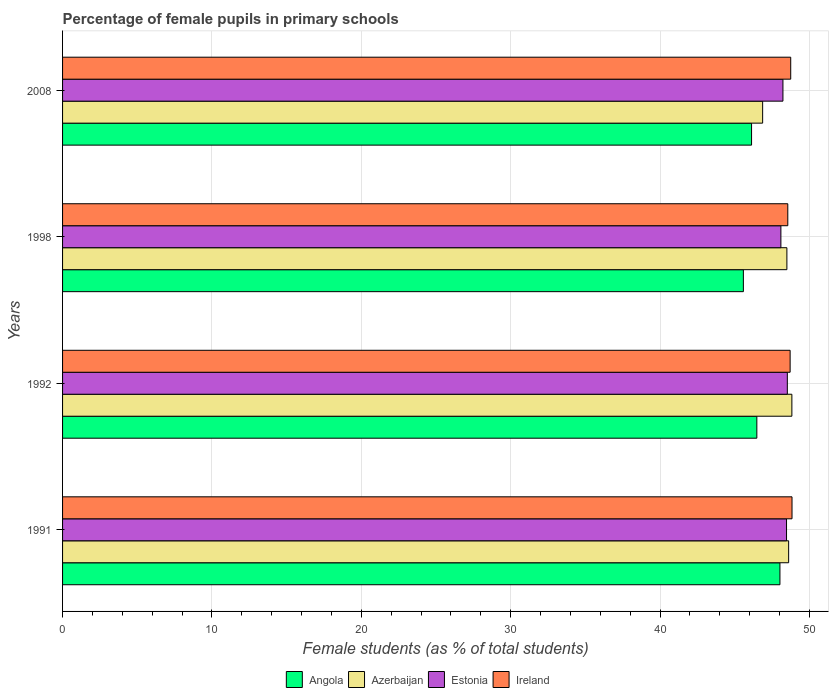Are the number of bars per tick equal to the number of legend labels?
Offer a very short reply. Yes. What is the label of the 3rd group of bars from the top?
Offer a very short reply. 1992. In how many cases, is the number of bars for a given year not equal to the number of legend labels?
Your answer should be very brief. 0. What is the percentage of female pupils in primary schools in Ireland in 2008?
Make the answer very short. 48.74. Across all years, what is the maximum percentage of female pupils in primary schools in Ireland?
Offer a terse response. 48.83. Across all years, what is the minimum percentage of female pupils in primary schools in Azerbaijan?
Ensure brevity in your answer.  46.87. What is the total percentage of female pupils in primary schools in Azerbaijan in the graph?
Make the answer very short. 192.78. What is the difference between the percentage of female pupils in primary schools in Angola in 1992 and that in 2008?
Provide a short and direct response. 0.35. What is the difference between the percentage of female pupils in primary schools in Estonia in 1992 and the percentage of female pupils in primary schools in Azerbaijan in 1998?
Offer a very short reply. 0.03. What is the average percentage of female pupils in primary schools in Azerbaijan per year?
Provide a succinct answer. 48.2. In the year 1998, what is the difference between the percentage of female pupils in primary schools in Estonia and percentage of female pupils in primary schools in Angola?
Your answer should be very brief. 2.51. What is the ratio of the percentage of female pupils in primary schools in Estonia in 1991 to that in 2008?
Make the answer very short. 1. What is the difference between the highest and the second highest percentage of female pupils in primary schools in Estonia?
Offer a terse response. 0.05. What is the difference between the highest and the lowest percentage of female pupils in primary schools in Estonia?
Keep it short and to the point. 0.43. In how many years, is the percentage of female pupils in primary schools in Angola greater than the average percentage of female pupils in primary schools in Angola taken over all years?
Make the answer very short. 1. What does the 4th bar from the top in 1998 represents?
Keep it short and to the point. Angola. What does the 2nd bar from the bottom in 2008 represents?
Offer a terse response. Azerbaijan. How many bars are there?
Make the answer very short. 16. Are all the bars in the graph horizontal?
Offer a terse response. Yes. What is the difference between two consecutive major ticks on the X-axis?
Provide a succinct answer. 10. Does the graph contain any zero values?
Offer a terse response. No. How are the legend labels stacked?
Provide a short and direct response. Horizontal. What is the title of the graph?
Provide a succinct answer. Percentage of female pupils in primary schools. Does "Brunei Darussalam" appear as one of the legend labels in the graph?
Make the answer very short. No. What is the label or title of the X-axis?
Offer a very short reply. Female students (as % of total students). What is the label or title of the Y-axis?
Provide a succinct answer. Years. What is the Female students (as % of total students) in Angola in 1991?
Your answer should be very brief. 48.02. What is the Female students (as % of total students) in Azerbaijan in 1991?
Your answer should be compact. 48.61. What is the Female students (as % of total students) of Estonia in 1991?
Your response must be concise. 48.46. What is the Female students (as % of total students) of Ireland in 1991?
Your answer should be compact. 48.83. What is the Female students (as % of total students) of Angola in 1992?
Your answer should be very brief. 46.48. What is the Female students (as % of total students) of Azerbaijan in 1992?
Ensure brevity in your answer.  48.82. What is the Female students (as % of total students) of Estonia in 1992?
Ensure brevity in your answer.  48.52. What is the Female students (as % of total students) in Ireland in 1992?
Make the answer very short. 48.71. What is the Female students (as % of total students) of Angola in 1998?
Keep it short and to the point. 45.58. What is the Female students (as % of total students) of Azerbaijan in 1998?
Make the answer very short. 48.49. What is the Female students (as % of total students) of Estonia in 1998?
Provide a short and direct response. 48.09. What is the Female students (as % of total students) of Ireland in 1998?
Give a very brief answer. 48.55. What is the Female students (as % of total students) in Angola in 2008?
Offer a very short reply. 46.12. What is the Female students (as % of total students) in Azerbaijan in 2008?
Make the answer very short. 46.87. What is the Female students (as % of total students) of Estonia in 2008?
Provide a succinct answer. 48.22. What is the Female students (as % of total students) of Ireland in 2008?
Your response must be concise. 48.74. Across all years, what is the maximum Female students (as % of total students) in Angola?
Keep it short and to the point. 48.02. Across all years, what is the maximum Female students (as % of total students) in Azerbaijan?
Your answer should be compact. 48.82. Across all years, what is the maximum Female students (as % of total students) of Estonia?
Your response must be concise. 48.52. Across all years, what is the maximum Female students (as % of total students) of Ireland?
Keep it short and to the point. 48.83. Across all years, what is the minimum Female students (as % of total students) of Angola?
Provide a short and direct response. 45.58. Across all years, what is the minimum Female students (as % of total students) of Azerbaijan?
Your answer should be very brief. 46.87. Across all years, what is the minimum Female students (as % of total students) of Estonia?
Give a very brief answer. 48.09. Across all years, what is the minimum Female students (as % of total students) in Ireland?
Keep it short and to the point. 48.55. What is the total Female students (as % of total students) in Angola in the graph?
Give a very brief answer. 186.2. What is the total Female students (as % of total students) in Azerbaijan in the graph?
Provide a short and direct response. 192.78. What is the total Female students (as % of total students) in Estonia in the graph?
Your answer should be compact. 193.29. What is the total Female students (as % of total students) of Ireland in the graph?
Your answer should be very brief. 194.83. What is the difference between the Female students (as % of total students) of Angola in 1991 and that in 1992?
Your answer should be very brief. 1.55. What is the difference between the Female students (as % of total students) of Azerbaijan in 1991 and that in 1992?
Your answer should be very brief. -0.22. What is the difference between the Female students (as % of total students) in Estonia in 1991 and that in 1992?
Give a very brief answer. -0.05. What is the difference between the Female students (as % of total students) of Ireland in 1991 and that in 1992?
Your response must be concise. 0.13. What is the difference between the Female students (as % of total students) in Angola in 1991 and that in 1998?
Make the answer very short. 2.45. What is the difference between the Female students (as % of total students) in Azerbaijan in 1991 and that in 1998?
Keep it short and to the point. 0.12. What is the difference between the Female students (as % of total students) of Estonia in 1991 and that in 1998?
Keep it short and to the point. 0.38. What is the difference between the Female students (as % of total students) in Ireland in 1991 and that in 1998?
Your response must be concise. 0.28. What is the difference between the Female students (as % of total students) of Angola in 1991 and that in 2008?
Provide a succinct answer. 1.9. What is the difference between the Female students (as % of total students) in Azerbaijan in 1991 and that in 2008?
Make the answer very short. 1.74. What is the difference between the Female students (as % of total students) of Estonia in 1991 and that in 2008?
Ensure brevity in your answer.  0.24. What is the difference between the Female students (as % of total students) of Ireland in 1991 and that in 2008?
Keep it short and to the point. 0.09. What is the difference between the Female students (as % of total students) in Angola in 1992 and that in 1998?
Make the answer very short. 0.9. What is the difference between the Female students (as % of total students) in Azerbaijan in 1992 and that in 1998?
Ensure brevity in your answer.  0.33. What is the difference between the Female students (as % of total students) in Estonia in 1992 and that in 1998?
Your answer should be compact. 0.43. What is the difference between the Female students (as % of total students) in Ireland in 1992 and that in 1998?
Provide a short and direct response. 0.16. What is the difference between the Female students (as % of total students) of Angola in 1992 and that in 2008?
Give a very brief answer. 0.35. What is the difference between the Female students (as % of total students) in Azerbaijan in 1992 and that in 2008?
Offer a terse response. 1.96. What is the difference between the Female students (as % of total students) in Estonia in 1992 and that in 2008?
Offer a very short reply. 0.29. What is the difference between the Female students (as % of total students) of Ireland in 1992 and that in 2008?
Ensure brevity in your answer.  -0.04. What is the difference between the Female students (as % of total students) in Angola in 1998 and that in 2008?
Your answer should be compact. -0.55. What is the difference between the Female students (as % of total students) of Azerbaijan in 1998 and that in 2008?
Offer a terse response. 1.62. What is the difference between the Female students (as % of total students) in Estonia in 1998 and that in 2008?
Keep it short and to the point. -0.14. What is the difference between the Female students (as % of total students) in Ireland in 1998 and that in 2008?
Ensure brevity in your answer.  -0.2. What is the difference between the Female students (as % of total students) of Angola in 1991 and the Female students (as % of total students) of Azerbaijan in 1992?
Offer a terse response. -0.8. What is the difference between the Female students (as % of total students) in Angola in 1991 and the Female students (as % of total students) in Estonia in 1992?
Provide a short and direct response. -0.5. What is the difference between the Female students (as % of total students) of Angola in 1991 and the Female students (as % of total students) of Ireland in 1992?
Your answer should be very brief. -0.68. What is the difference between the Female students (as % of total students) in Azerbaijan in 1991 and the Female students (as % of total students) in Estonia in 1992?
Your answer should be very brief. 0.09. What is the difference between the Female students (as % of total students) of Azerbaijan in 1991 and the Female students (as % of total students) of Ireland in 1992?
Give a very brief answer. -0.1. What is the difference between the Female students (as % of total students) of Estonia in 1991 and the Female students (as % of total students) of Ireland in 1992?
Your answer should be very brief. -0.24. What is the difference between the Female students (as % of total students) of Angola in 1991 and the Female students (as % of total students) of Azerbaijan in 1998?
Your answer should be very brief. -0.47. What is the difference between the Female students (as % of total students) in Angola in 1991 and the Female students (as % of total students) in Estonia in 1998?
Your answer should be very brief. -0.06. What is the difference between the Female students (as % of total students) of Angola in 1991 and the Female students (as % of total students) of Ireland in 1998?
Your answer should be compact. -0.53. What is the difference between the Female students (as % of total students) of Azerbaijan in 1991 and the Female students (as % of total students) of Estonia in 1998?
Make the answer very short. 0.52. What is the difference between the Female students (as % of total students) of Azerbaijan in 1991 and the Female students (as % of total students) of Ireland in 1998?
Keep it short and to the point. 0.06. What is the difference between the Female students (as % of total students) of Estonia in 1991 and the Female students (as % of total students) of Ireland in 1998?
Your answer should be very brief. -0.08. What is the difference between the Female students (as % of total students) of Angola in 1991 and the Female students (as % of total students) of Azerbaijan in 2008?
Give a very brief answer. 1.16. What is the difference between the Female students (as % of total students) of Angola in 1991 and the Female students (as % of total students) of Estonia in 2008?
Give a very brief answer. -0.2. What is the difference between the Female students (as % of total students) in Angola in 1991 and the Female students (as % of total students) in Ireland in 2008?
Your answer should be compact. -0.72. What is the difference between the Female students (as % of total students) in Azerbaijan in 1991 and the Female students (as % of total students) in Estonia in 2008?
Keep it short and to the point. 0.38. What is the difference between the Female students (as % of total students) in Azerbaijan in 1991 and the Female students (as % of total students) in Ireland in 2008?
Your answer should be very brief. -0.14. What is the difference between the Female students (as % of total students) of Estonia in 1991 and the Female students (as % of total students) of Ireland in 2008?
Your answer should be very brief. -0.28. What is the difference between the Female students (as % of total students) in Angola in 1992 and the Female students (as % of total students) in Azerbaijan in 1998?
Your answer should be compact. -2.01. What is the difference between the Female students (as % of total students) in Angola in 1992 and the Female students (as % of total students) in Estonia in 1998?
Ensure brevity in your answer.  -1.61. What is the difference between the Female students (as % of total students) of Angola in 1992 and the Female students (as % of total students) of Ireland in 1998?
Offer a terse response. -2.07. What is the difference between the Female students (as % of total students) of Azerbaijan in 1992 and the Female students (as % of total students) of Estonia in 1998?
Give a very brief answer. 0.74. What is the difference between the Female students (as % of total students) of Azerbaijan in 1992 and the Female students (as % of total students) of Ireland in 1998?
Give a very brief answer. 0.27. What is the difference between the Female students (as % of total students) in Estonia in 1992 and the Female students (as % of total students) in Ireland in 1998?
Give a very brief answer. -0.03. What is the difference between the Female students (as % of total students) of Angola in 1992 and the Female students (as % of total students) of Azerbaijan in 2008?
Provide a short and direct response. -0.39. What is the difference between the Female students (as % of total students) of Angola in 1992 and the Female students (as % of total students) of Estonia in 2008?
Make the answer very short. -1.75. What is the difference between the Female students (as % of total students) in Angola in 1992 and the Female students (as % of total students) in Ireland in 2008?
Provide a short and direct response. -2.27. What is the difference between the Female students (as % of total students) in Azerbaijan in 1992 and the Female students (as % of total students) in Estonia in 2008?
Ensure brevity in your answer.  0.6. What is the difference between the Female students (as % of total students) of Azerbaijan in 1992 and the Female students (as % of total students) of Ireland in 2008?
Your response must be concise. 0.08. What is the difference between the Female students (as % of total students) in Estonia in 1992 and the Female students (as % of total students) in Ireland in 2008?
Provide a succinct answer. -0.23. What is the difference between the Female students (as % of total students) of Angola in 1998 and the Female students (as % of total students) of Azerbaijan in 2008?
Offer a very short reply. -1.29. What is the difference between the Female students (as % of total students) of Angola in 1998 and the Female students (as % of total students) of Estonia in 2008?
Keep it short and to the point. -2.65. What is the difference between the Female students (as % of total students) of Angola in 1998 and the Female students (as % of total students) of Ireland in 2008?
Provide a short and direct response. -3.17. What is the difference between the Female students (as % of total students) of Azerbaijan in 1998 and the Female students (as % of total students) of Estonia in 2008?
Make the answer very short. 0.27. What is the difference between the Female students (as % of total students) of Azerbaijan in 1998 and the Female students (as % of total students) of Ireland in 2008?
Offer a very short reply. -0.26. What is the difference between the Female students (as % of total students) in Estonia in 1998 and the Female students (as % of total students) in Ireland in 2008?
Provide a succinct answer. -0.66. What is the average Female students (as % of total students) in Angola per year?
Your response must be concise. 46.55. What is the average Female students (as % of total students) of Azerbaijan per year?
Offer a very short reply. 48.2. What is the average Female students (as % of total students) in Estonia per year?
Give a very brief answer. 48.32. What is the average Female students (as % of total students) of Ireland per year?
Provide a succinct answer. 48.71. In the year 1991, what is the difference between the Female students (as % of total students) of Angola and Female students (as % of total students) of Azerbaijan?
Your answer should be very brief. -0.58. In the year 1991, what is the difference between the Female students (as % of total students) in Angola and Female students (as % of total students) in Estonia?
Offer a very short reply. -0.44. In the year 1991, what is the difference between the Female students (as % of total students) of Angola and Female students (as % of total students) of Ireland?
Provide a short and direct response. -0.81. In the year 1991, what is the difference between the Female students (as % of total students) in Azerbaijan and Female students (as % of total students) in Estonia?
Your answer should be very brief. 0.14. In the year 1991, what is the difference between the Female students (as % of total students) of Azerbaijan and Female students (as % of total students) of Ireland?
Ensure brevity in your answer.  -0.23. In the year 1991, what is the difference between the Female students (as % of total students) of Estonia and Female students (as % of total students) of Ireland?
Provide a short and direct response. -0.37. In the year 1992, what is the difference between the Female students (as % of total students) of Angola and Female students (as % of total students) of Azerbaijan?
Your response must be concise. -2.35. In the year 1992, what is the difference between the Female students (as % of total students) of Angola and Female students (as % of total students) of Estonia?
Your answer should be compact. -2.04. In the year 1992, what is the difference between the Female students (as % of total students) in Angola and Female students (as % of total students) in Ireland?
Give a very brief answer. -2.23. In the year 1992, what is the difference between the Female students (as % of total students) of Azerbaijan and Female students (as % of total students) of Estonia?
Ensure brevity in your answer.  0.3. In the year 1992, what is the difference between the Female students (as % of total students) of Azerbaijan and Female students (as % of total students) of Ireland?
Ensure brevity in your answer.  0.12. In the year 1992, what is the difference between the Female students (as % of total students) in Estonia and Female students (as % of total students) in Ireland?
Your answer should be very brief. -0.19. In the year 1998, what is the difference between the Female students (as % of total students) in Angola and Female students (as % of total students) in Azerbaijan?
Offer a very short reply. -2.91. In the year 1998, what is the difference between the Female students (as % of total students) in Angola and Female students (as % of total students) in Estonia?
Give a very brief answer. -2.51. In the year 1998, what is the difference between the Female students (as % of total students) of Angola and Female students (as % of total students) of Ireland?
Give a very brief answer. -2.97. In the year 1998, what is the difference between the Female students (as % of total students) in Azerbaijan and Female students (as % of total students) in Estonia?
Offer a terse response. 0.4. In the year 1998, what is the difference between the Female students (as % of total students) of Azerbaijan and Female students (as % of total students) of Ireland?
Keep it short and to the point. -0.06. In the year 1998, what is the difference between the Female students (as % of total students) in Estonia and Female students (as % of total students) in Ireland?
Ensure brevity in your answer.  -0.46. In the year 2008, what is the difference between the Female students (as % of total students) in Angola and Female students (as % of total students) in Azerbaijan?
Offer a terse response. -0.74. In the year 2008, what is the difference between the Female students (as % of total students) of Angola and Female students (as % of total students) of Estonia?
Offer a very short reply. -2.1. In the year 2008, what is the difference between the Female students (as % of total students) of Angola and Female students (as % of total students) of Ireland?
Ensure brevity in your answer.  -2.62. In the year 2008, what is the difference between the Female students (as % of total students) of Azerbaijan and Female students (as % of total students) of Estonia?
Your response must be concise. -1.36. In the year 2008, what is the difference between the Female students (as % of total students) in Azerbaijan and Female students (as % of total students) in Ireland?
Ensure brevity in your answer.  -1.88. In the year 2008, what is the difference between the Female students (as % of total students) of Estonia and Female students (as % of total students) of Ireland?
Keep it short and to the point. -0.52. What is the ratio of the Female students (as % of total students) of Angola in 1991 to that in 1992?
Offer a terse response. 1.03. What is the ratio of the Female students (as % of total students) in Azerbaijan in 1991 to that in 1992?
Provide a short and direct response. 1. What is the ratio of the Female students (as % of total students) of Estonia in 1991 to that in 1992?
Your response must be concise. 1. What is the ratio of the Female students (as % of total students) of Ireland in 1991 to that in 1992?
Your answer should be compact. 1. What is the ratio of the Female students (as % of total students) of Angola in 1991 to that in 1998?
Provide a short and direct response. 1.05. What is the ratio of the Female students (as % of total students) of Estonia in 1991 to that in 1998?
Keep it short and to the point. 1.01. What is the ratio of the Female students (as % of total students) of Angola in 1991 to that in 2008?
Your answer should be compact. 1.04. What is the ratio of the Female students (as % of total students) in Azerbaijan in 1991 to that in 2008?
Make the answer very short. 1.04. What is the ratio of the Female students (as % of total students) in Estonia in 1991 to that in 2008?
Provide a short and direct response. 1. What is the ratio of the Female students (as % of total students) in Ireland in 1991 to that in 2008?
Give a very brief answer. 1. What is the ratio of the Female students (as % of total students) in Angola in 1992 to that in 1998?
Your answer should be compact. 1.02. What is the ratio of the Female students (as % of total students) in Azerbaijan in 1992 to that in 1998?
Offer a very short reply. 1.01. What is the ratio of the Female students (as % of total students) in Ireland in 1992 to that in 1998?
Your response must be concise. 1. What is the ratio of the Female students (as % of total students) of Angola in 1992 to that in 2008?
Provide a short and direct response. 1.01. What is the ratio of the Female students (as % of total students) of Azerbaijan in 1992 to that in 2008?
Give a very brief answer. 1.04. What is the ratio of the Female students (as % of total students) of Estonia in 1992 to that in 2008?
Make the answer very short. 1.01. What is the ratio of the Female students (as % of total students) in Azerbaijan in 1998 to that in 2008?
Your answer should be very brief. 1.03. What is the difference between the highest and the second highest Female students (as % of total students) of Angola?
Make the answer very short. 1.55. What is the difference between the highest and the second highest Female students (as % of total students) of Azerbaijan?
Offer a terse response. 0.22. What is the difference between the highest and the second highest Female students (as % of total students) of Estonia?
Your answer should be compact. 0.05. What is the difference between the highest and the second highest Female students (as % of total students) in Ireland?
Give a very brief answer. 0.09. What is the difference between the highest and the lowest Female students (as % of total students) of Angola?
Offer a very short reply. 2.45. What is the difference between the highest and the lowest Female students (as % of total students) of Azerbaijan?
Your response must be concise. 1.96. What is the difference between the highest and the lowest Female students (as % of total students) in Estonia?
Your answer should be very brief. 0.43. What is the difference between the highest and the lowest Female students (as % of total students) in Ireland?
Offer a terse response. 0.28. 